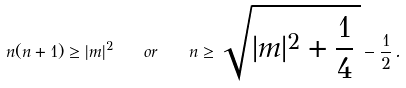Convert formula to latex. <formula><loc_0><loc_0><loc_500><loc_500>n ( n + 1 ) \geq | m | ^ { 2 } \quad o r \quad n \geq \sqrt { | m | ^ { 2 } + \frac { 1 } { 4 } \, } - \frac { 1 } { 2 } \, .</formula> 